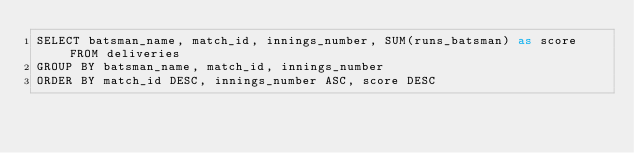<code> <loc_0><loc_0><loc_500><loc_500><_SQL_>SELECT batsman_name, match_id, innings_number, SUM(runs_batsman) as score FROM deliveries
GROUP BY batsman_name, match_id, innings_number
ORDER BY match_id DESC, innings_number ASC, score DESC</code> 